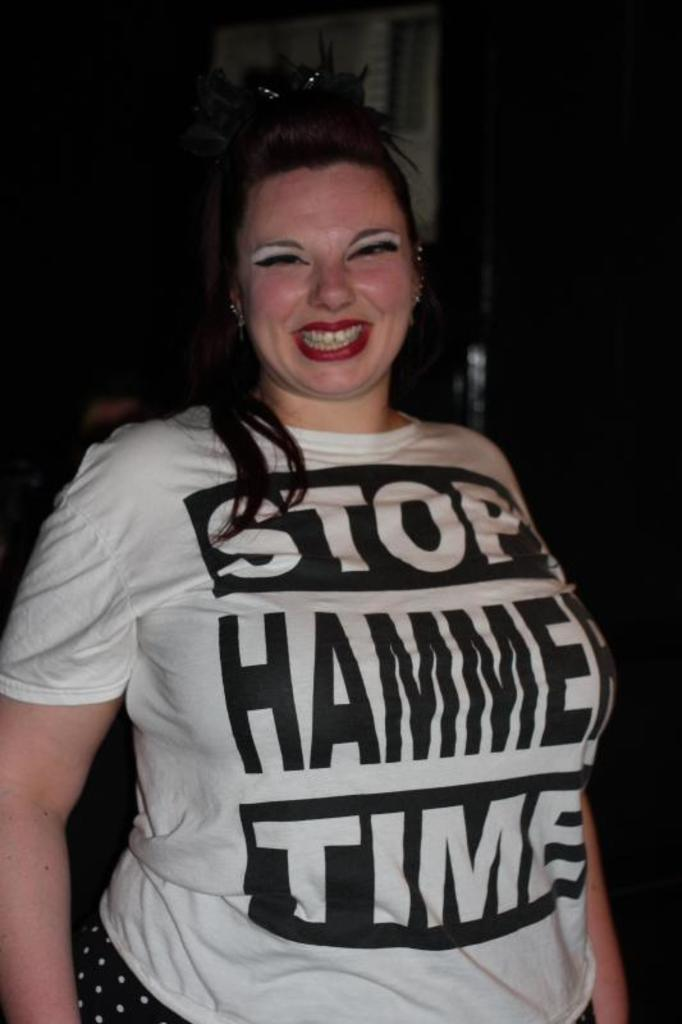<image>
Share a concise interpretation of the image provided. The woman is smiling as she wears a MC Hammer, Hammer Time shirt. 